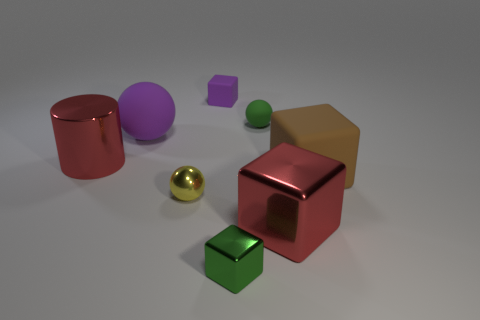Is there any other thing that has the same material as the tiny purple object?
Your answer should be very brief. Yes. How big is the metallic block that is left of the red shiny thing on the right side of the metallic cube left of the big red metal block?
Give a very brief answer. Small. The rubber thing that is the same color as the large sphere is what shape?
Provide a short and direct response. Cube. There is a tiny green object behind the large cylinder; what is its shape?
Provide a short and direct response. Sphere. There is a green matte thing that is the same size as the green cube; what is its shape?
Your answer should be compact. Sphere. There is a big metallic thing that is behind the large block that is to the right of the large red metal thing right of the big red metallic cylinder; what is its color?
Provide a succinct answer. Red. Is the brown thing the same shape as the green metallic object?
Your answer should be very brief. Yes. Are there the same number of green rubber balls that are in front of the small green ball and yellow spheres?
Your answer should be very brief. No. How many other objects are the same material as the red cylinder?
Keep it short and to the point. 3. There is a red metallic object behind the red cube; is it the same size as the rubber ball that is to the right of the tiny purple object?
Your answer should be very brief. No. 